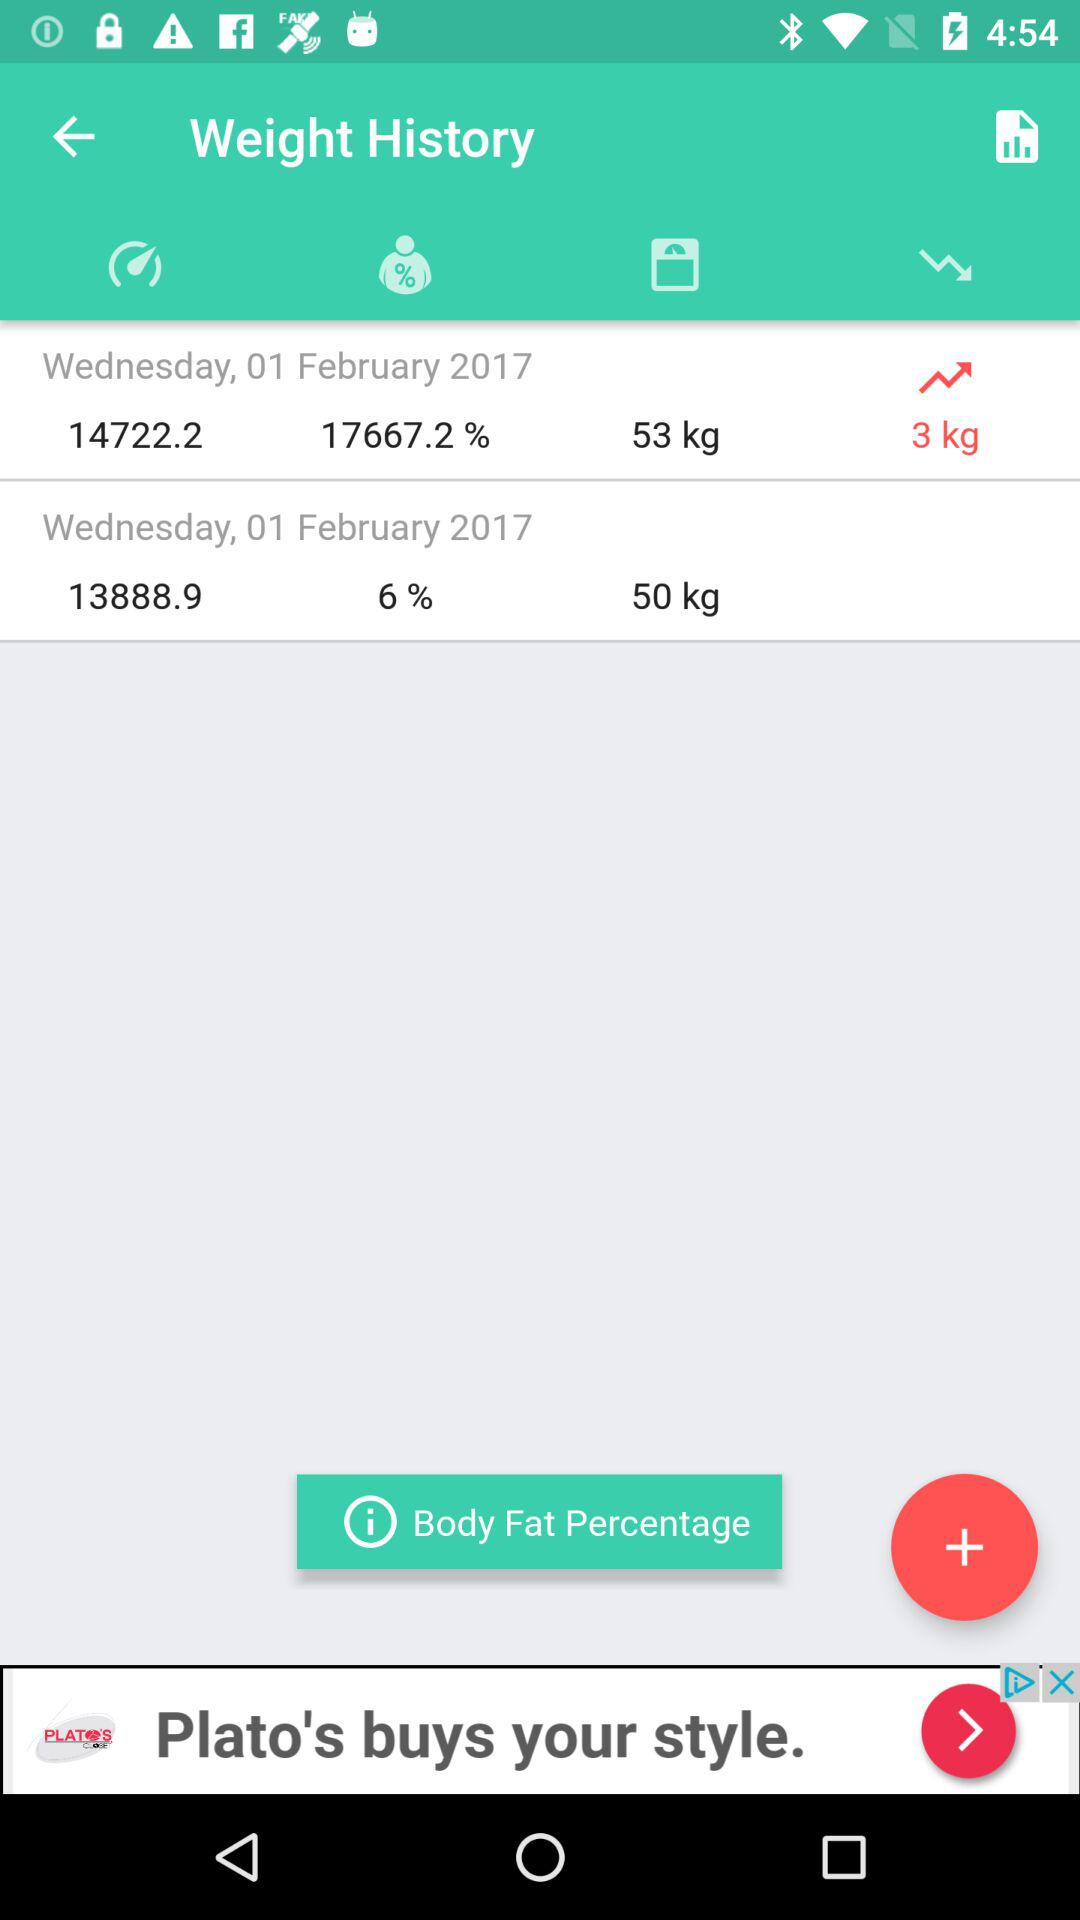What is the day on 1 February 2017? The day on 1 February 2017 is Wednesday. 